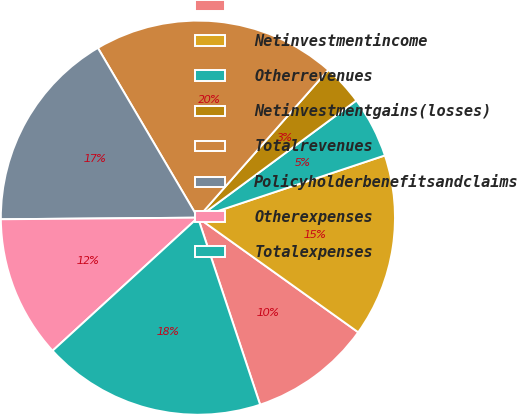<chart> <loc_0><loc_0><loc_500><loc_500><pie_chart><ecel><fcel>Netinvestmentincome<fcel>Otherrevenues<fcel>Netinvestmentgains(losses)<fcel>Totalrevenues<fcel>Policyholderbenefitsandclaims<fcel>Otherexpenses<fcel>Totalexpenses<nl><fcel>10.01%<fcel>14.99%<fcel>5.02%<fcel>3.36%<fcel>19.98%<fcel>16.65%<fcel>11.67%<fcel>18.31%<nl></chart> 